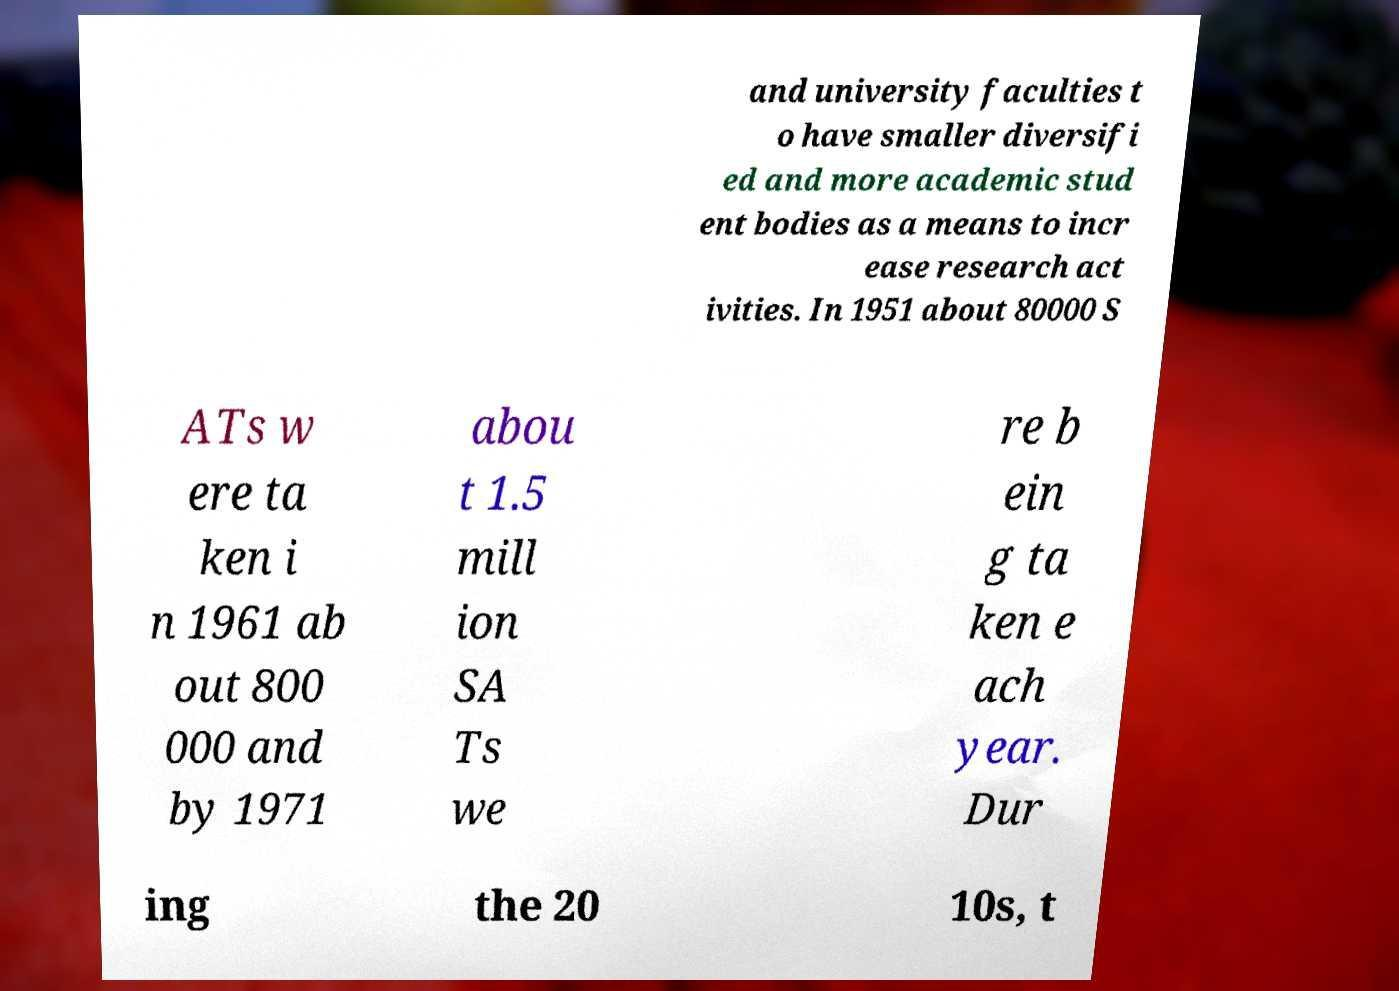Please read and relay the text visible in this image. What does it say? and university faculties t o have smaller diversifi ed and more academic stud ent bodies as a means to incr ease research act ivities. In 1951 about 80000 S ATs w ere ta ken i n 1961 ab out 800 000 and by 1971 abou t 1.5 mill ion SA Ts we re b ein g ta ken e ach year. Dur ing the 20 10s, t 